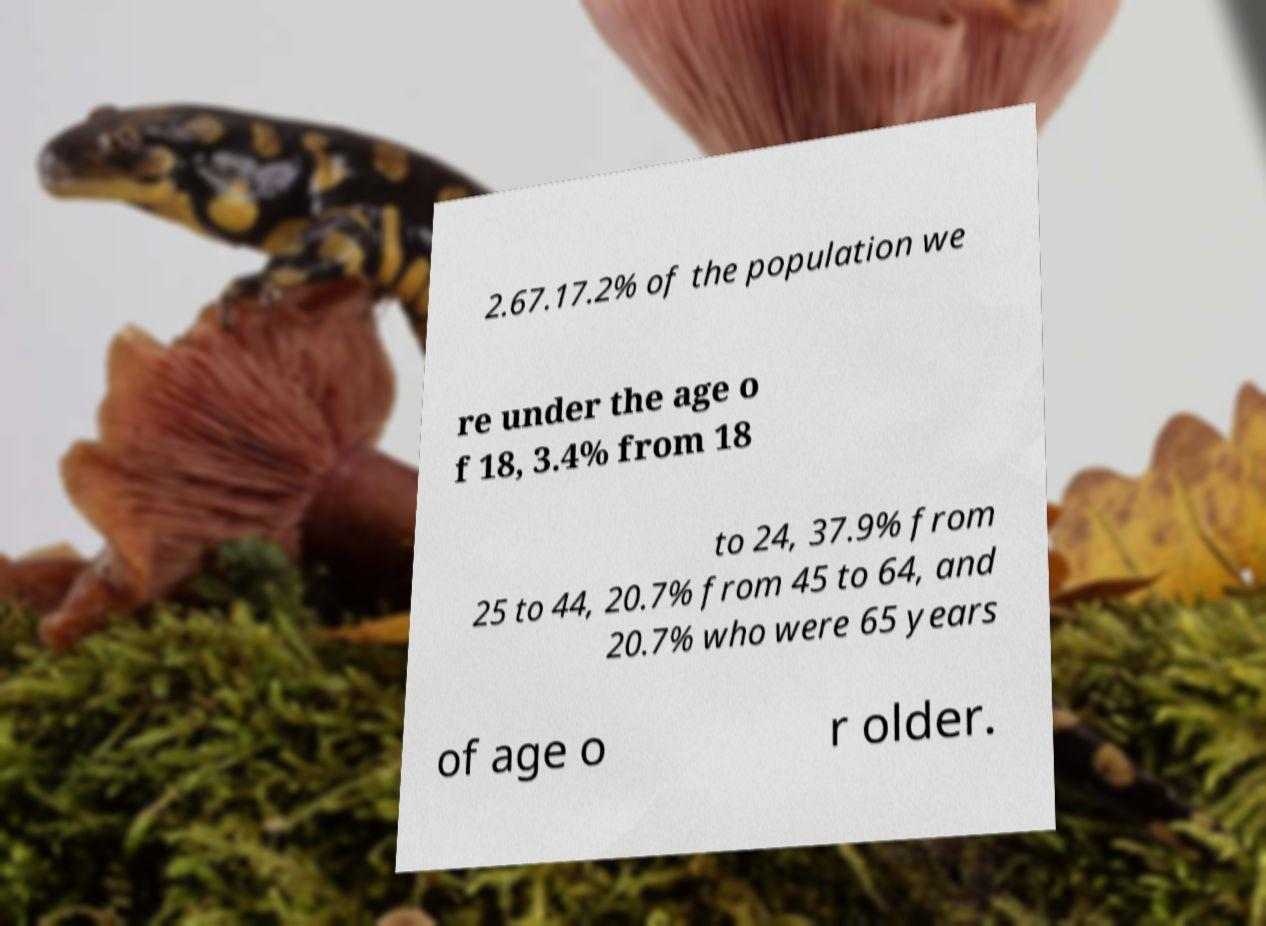Could you assist in decoding the text presented in this image and type it out clearly? 2.67.17.2% of the population we re under the age o f 18, 3.4% from 18 to 24, 37.9% from 25 to 44, 20.7% from 45 to 64, and 20.7% who were 65 years of age o r older. 